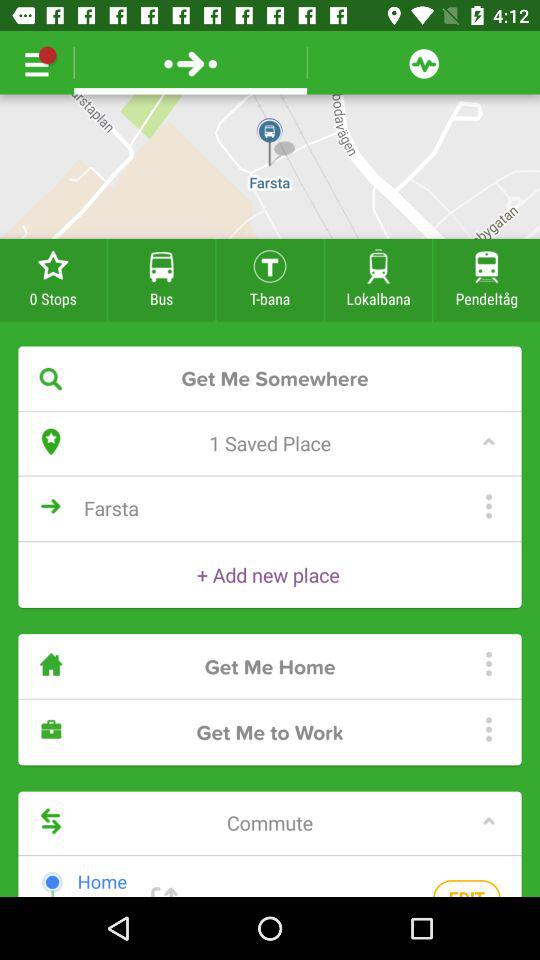How many stops are there? There are 0 steps. 